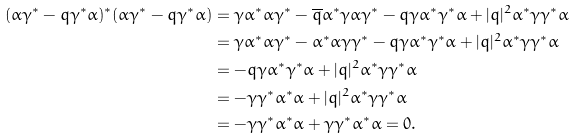Convert formula to latex. <formula><loc_0><loc_0><loc_500><loc_500>( \alpha \gamma ^ { * } - q \gamma ^ { * } \alpha ) ^ { * } ( \alpha \gamma ^ { * } - q \gamma ^ { * } \alpha ) & = \gamma \alpha ^ { * } \alpha \gamma ^ { * } - \overline { q } \alpha ^ { * } \gamma \alpha \gamma ^ { * } - q \gamma \alpha ^ { * } \gamma ^ { * } \alpha + | q | ^ { 2 } \alpha ^ { * } \gamma \gamma ^ { * } \alpha \\ & = \gamma \alpha ^ { * } \alpha \gamma ^ { * } - \alpha ^ { * } \alpha \gamma \gamma ^ { * } - q \gamma \alpha ^ { * } \gamma ^ { * } \alpha + | q | ^ { 2 } \alpha ^ { * } \gamma \gamma ^ { * } \alpha \\ & = - q \gamma \alpha ^ { * } \gamma ^ { * } \alpha + | q | ^ { 2 } \alpha ^ { * } \gamma \gamma ^ { * } \alpha \\ & = - \gamma \gamma ^ { * } \alpha ^ { * } \alpha + | q | ^ { 2 } \alpha ^ { * } \gamma \gamma ^ { * } \alpha \\ & = - \gamma \gamma ^ { * } \alpha ^ { * } \alpha + \gamma \gamma ^ { * } \alpha ^ { * } \alpha = 0 .</formula> 